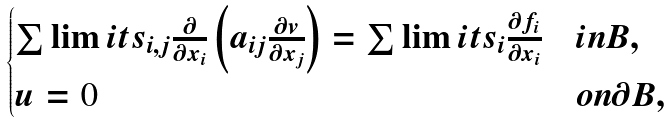Convert formula to latex. <formula><loc_0><loc_0><loc_500><loc_500>\begin{cases} \sum \lim i t s _ { i , j } \frac { \partial } { \partial x _ { i } } \left ( a _ { i j } \frac { \partial v } { \partial x _ { j } } \right ) = \sum \lim i t s _ { i } \frac { \partial f _ { i } } { \partial x _ { i } } & i n B , \\ u = 0 & o n \partial { B } , \end{cases}</formula> 